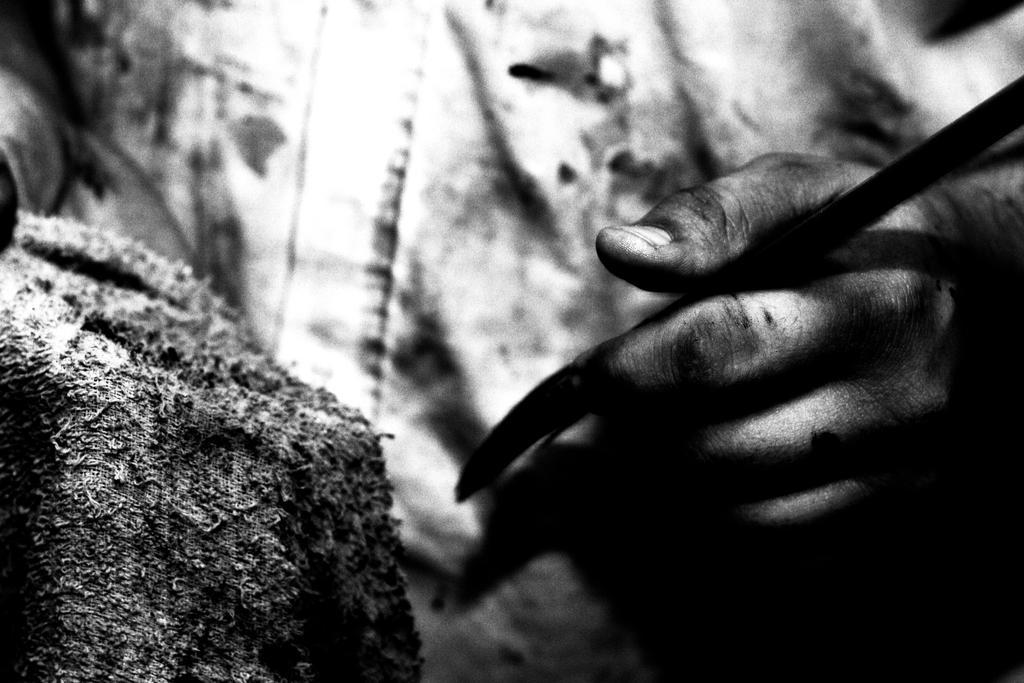Can you describe this image briefly? In this image there is a person's hand holding something. 